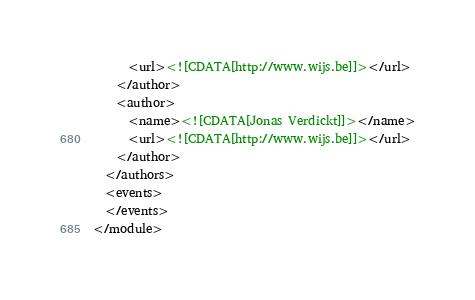<code> <loc_0><loc_0><loc_500><loc_500><_XML_>      <url><![CDATA[http://www.wijs.be]]></url>
    </author>
    <author>
      <name><![CDATA[Jonas Verdickt]]></name>
      <url><![CDATA[http://www.wijs.be]]></url>
    </author>
  </authors>
  <events>
  </events>
</module>
</code> 